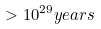<formula> <loc_0><loc_0><loc_500><loc_500>> 1 0 ^ { 2 9 } y e a r s</formula> 